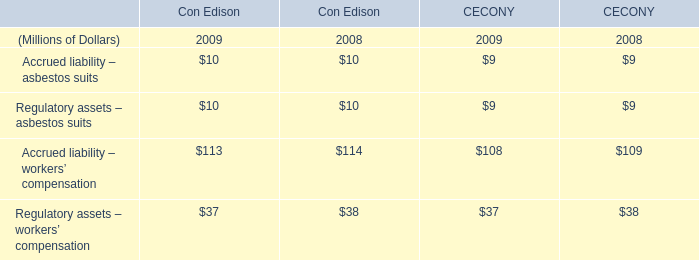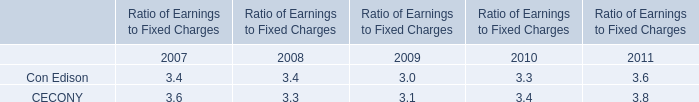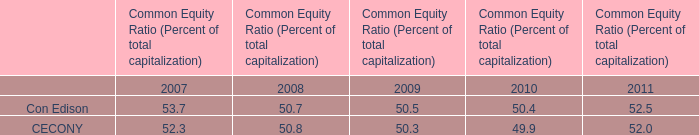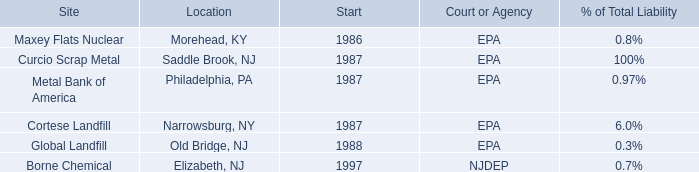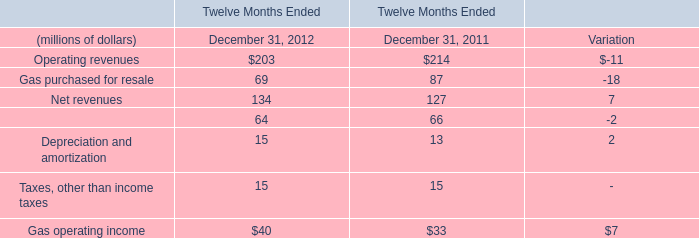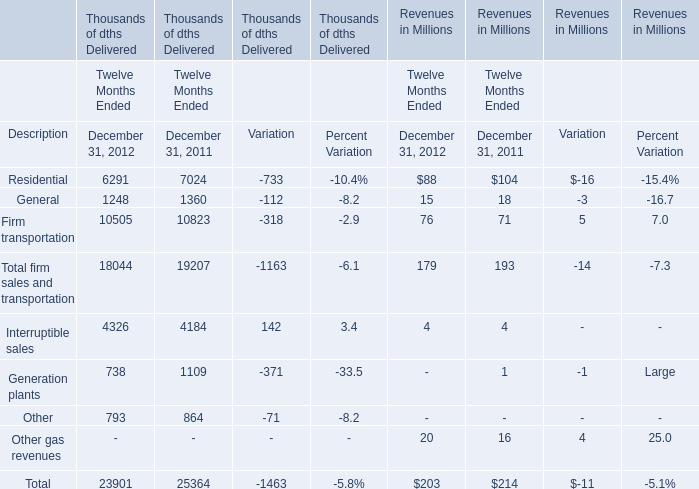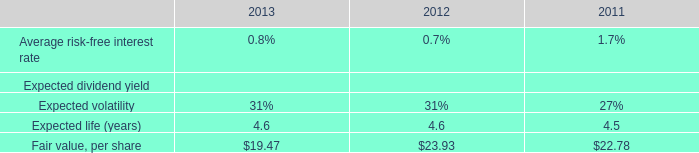What is the sum of Residential, General and Firm transportation in Revenues in Millions in 2012? (in millions) 
Computations: ((88 + 15) + 76)
Answer: 179.0. 